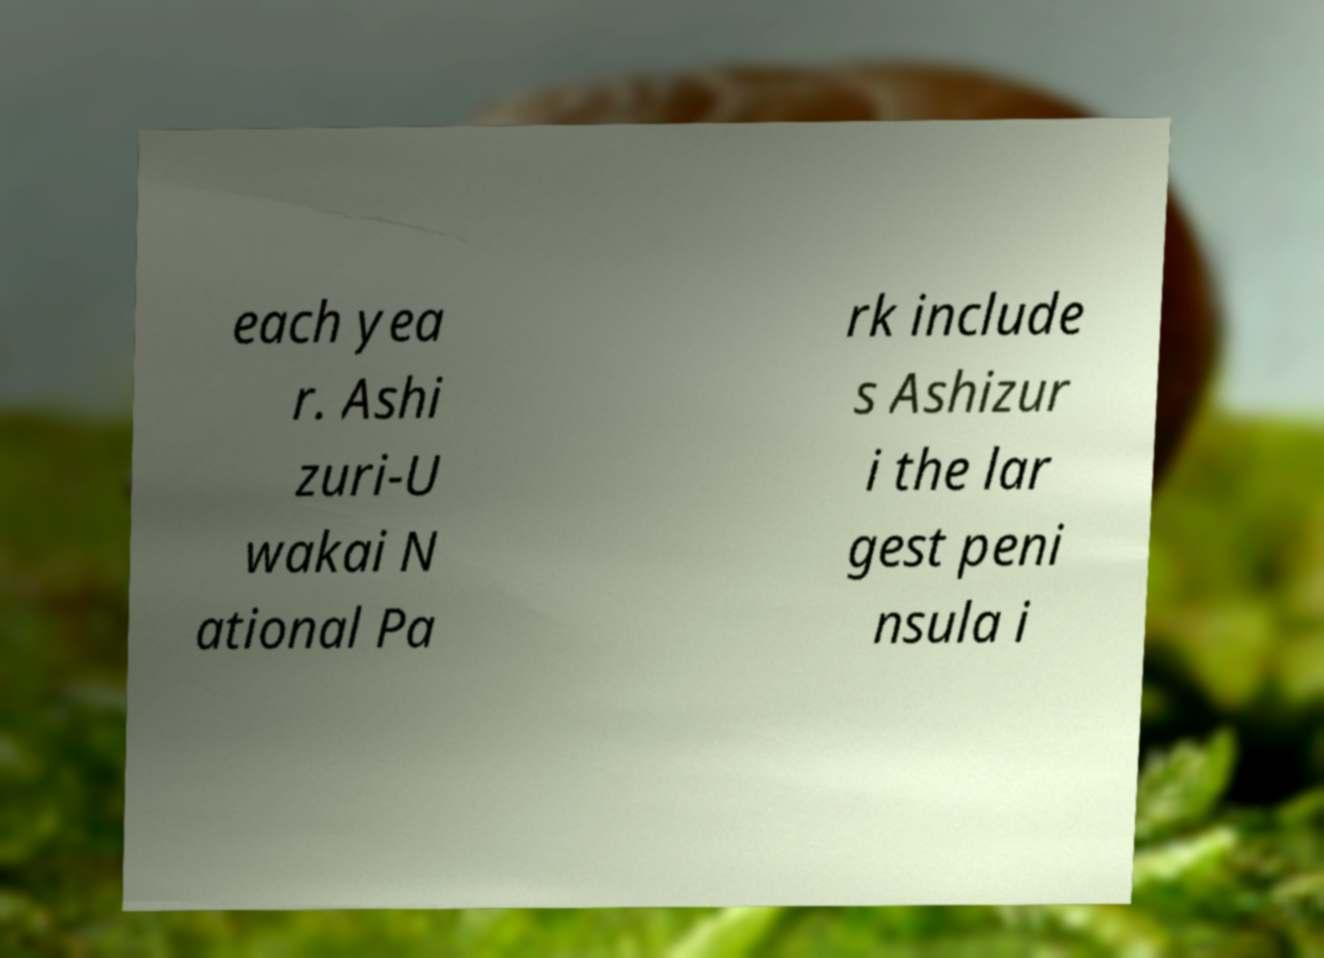Could you assist in decoding the text presented in this image and type it out clearly? each yea r. Ashi zuri-U wakai N ational Pa rk include s Ashizur i the lar gest peni nsula i 